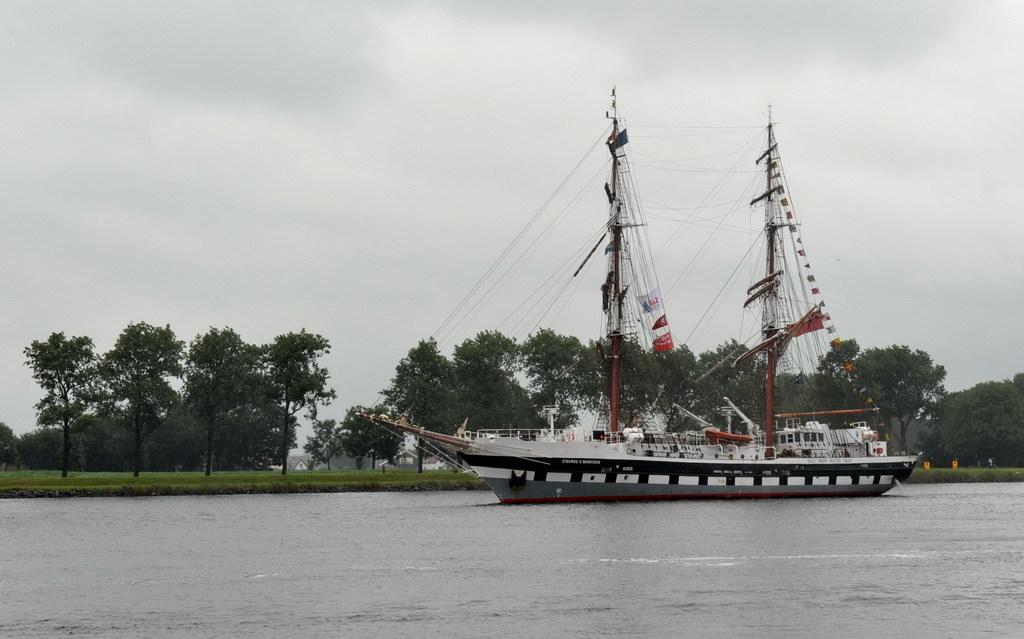What is located at the bottom of the image? There is water at the bottom of the image. What is the main subject in the middle of the image? There is a ship in the middle of the image. What type of vegetation can be seen in the background of the image? There are trees in the background of the image. What is visible at the top of the image? The sky is visible at the top of the image. What news is being reported in the image? There is no news being reported in the image; it features a ship on water with trees and sky in the background. What plot is being developed in the image? There is no plot being developed in the image; it is a static scene of a ship on water. 